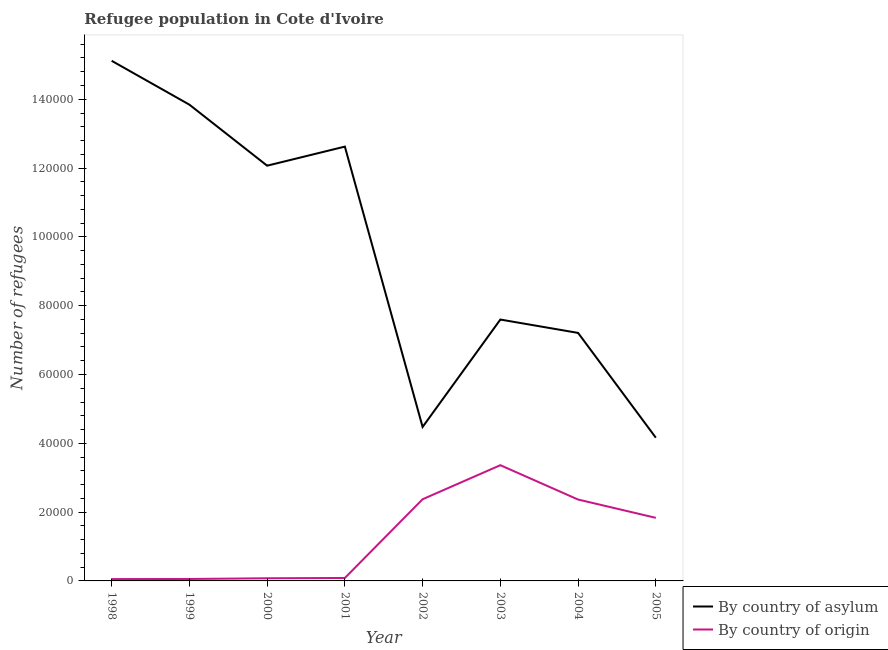Does the line corresponding to number of refugees by country of origin intersect with the line corresponding to number of refugees by country of asylum?
Provide a short and direct response. No. Is the number of lines equal to the number of legend labels?
Give a very brief answer. Yes. What is the number of refugees by country of asylum in 2005?
Give a very brief answer. 4.16e+04. Across all years, what is the maximum number of refugees by country of asylum?
Your response must be concise. 1.51e+05. Across all years, what is the minimum number of refugees by country of origin?
Your answer should be very brief. 537. In which year was the number of refugees by country of origin maximum?
Give a very brief answer. 2003. In which year was the number of refugees by country of origin minimum?
Your answer should be very brief. 1998. What is the total number of refugees by country of origin in the graph?
Ensure brevity in your answer.  1.02e+05. What is the difference between the number of refugees by country of origin in 1998 and that in 2004?
Offer a terse response. -2.31e+04. What is the difference between the number of refugees by country of asylum in 2005 and the number of refugees by country of origin in 2001?
Provide a succinct answer. 4.08e+04. What is the average number of refugees by country of origin per year?
Offer a terse response. 1.28e+04. In the year 1998, what is the difference between the number of refugees by country of origin and number of refugees by country of asylum?
Provide a short and direct response. -1.51e+05. What is the ratio of the number of refugees by country of origin in 1998 to that in 2002?
Your response must be concise. 0.02. Is the difference between the number of refugees by country of asylum in 2003 and 2005 greater than the difference between the number of refugees by country of origin in 2003 and 2005?
Your response must be concise. Yes. What is the difference between the highest and the second highest number of refugees by country of asylum?
Offer a very short reply. 1.28e+04. What is the difference between the highest and the lowest number of refugees by country of origin?
Offer a terse response. 3.31e+04. Is the sum of the number of refugees by country of asylum in 2001 and 2003 greater than the maximum number of refugees by country of origin across all years?
Provide a succinct answer. Yes. Does the number of refugees by country of asylum monotonically increase over the years?
Provide a short and direct response. No. Is the number of refugees by country of origin strictly greater than the number of refugees by country of asylum over the years?
Your answer should be compact. No. How many lines are there?
Make the answer very short. 2. How many years are there in the graph?
Your response must be concise. 8. What is the difference between two consecutive major ticks on the Y-axis?
Provide a short and direct response. 2.00e+04. Does the graph contain any zero values?
Keep it short and to the point. No. Does the graph contain grids?
Your response must be concise. No. Where does the legend appear in the graph?
Offer a very short reply. Bottom right. How many legend labels are there?
Your answer should be compact. 2. What is the title of the graph?
Ensure brevity in your answer.  Refugee population in Cote d'Ivoire. What is the label or title of the Y-axis?
Your answer should be compact. Number of refugees. What is the Number of refugees of By country of asylum in 1998?
Make the answer very short. 1.51e+05. What is the Number of refugees of By country of origin in 1998?
Provide a short and direct response. 537. What is the Number of refugees in By country of asylum in 1999?
Your answer should be compact. 1.38e+05. What is the Number of refugees of By country of origin in 1999?
Provide a succinct answer. 562. What is the Number of refugees of By country of asylum in 2000?
Offer a terse response. 1.21e+05. What is the Number of refugees in By country of origin in 2000?
Ensure brevity in your answer.  773. What is the Number of refugees of By country of asylum in 2001?
Provide a short and direct response. 1.26e+05. What is the Number of refugees in By country of origin in 2001?
Your response must be concise. 858. What is the Number of refugees of By country of asylum in 2002?
Make the answer very short. 4.47e+04. What is the Number of refugees in By country of origin in 2002?
Give a very brief answer. 2.37e+04. What is the Number of refugees in By country of asylum in 2003?
Provide a short and direct response. 7.60e+04. What is the Number of refugees in By country of origin in 2003?
Ensure brevity in your answer.  3.36e+04. What is the Number of refugees of By country of asylum in 2004?
Offer a very short reply. 7.21e+04. What is the Number of refugees of By country of origin in 2004?
Your response must be concise. 2.37e+04. What is the Number of refugees in By country of asylum in 2005?
Your response must be concise. 4.16e+04. What is the Number of refugees in By country of origin in 2005?
Make the answer very short. 1.83e+04. Across all years, what is the maximum Number of refugees in By country of asylum?
Your answer should be very brief. 1.51e+05. Across all years, what is the maximum Number of refugees in By country of origin?
Your answer should be compact. 3.36e+04. Across all years, what is the minimum Number of refugees of By country of asylum?
Offer a terse response. 4.16e+04. Across all years, what is the minimum Number of refugees in By country of origin?
Make the answer very short. 537. What is the total Number of refugees in By country of asylum in the graph?
Your answer should be compact. 7.71e+05. What is the total Number of refugees of By country of origin in the graph?
Provide a succinct answer. 1.02e+05. What is the difference between the Number of refugees in By country of asylum in 1998 and that in 1999?
Your answer should be very brief. 1.28e+04. What is the difference between the Number of refugees in By country of asylum in 1998 and that in 2000?
Your answer should be very brief. 3.05e+04. What is the difference between the Number of refugees of By country of origin in 1998 and that in 2000?
Offer a very short reply. -236. What is the difference between the Number of refugees in By country of asylum in 1998 and that in 2001?
Your response must be concise. 2.49e+04. What is the difference between the Number of refugees in By country of origin in 1998 and that in 2001?
Offer a terse response. -321. What is the difference between the Number of refugees in By country of asylum in 1998 and that in 2002?
Provide a succinct answer. 1.06e+05. What is the difference between the Number of refugees in By country of origin in 1998 and that in 2002?
Provide a succinct answer. -2.32e+04. What is the difference between the Number of refugees in By country of asylum in 1998 and that in 2003?
Ensure brevity in your answer.  7.52e+04. What is the difference between the Number of refugees of By country of origin in 1998 and that in 2003?
Provide a short and direct response. -3.31e+04. What is the difference between the Number of refugees of By country of asylum in 1998 and that in 2004?
Give a very brief answer. 7.91e+04. What is the difference between the Number of refugees in By country of origin in 1998 and that in 2004?
Provide a short and direct response. -2.31e+04. What is the difference between the Number of refugees of By country of asylum in 1998 and that in 2005?
Ensure brevity in your answer.  1.10e+05. What is the difference between the Number of refugees in By country of origin in 1998 and that in 2005?
Offer a terse response. -1.78e+04. What is the difference between the Number of refugees of By country of asylum in 1999 and that in 2000?
Give a very brief answer. 1.77e+04. What is the difference between the Number of refugees in By country of origin in 1999 and that in 2000?
Provide a succinct answer. -211. What is the difference between the Number of refugees in By country of asylum in 1999 and that in 2001?
Make the answer very short. 1.22e+04. What is the difference between the Number of refugees of By country of origin in 1999 and that in 2001?
Provide a succinct answer. -296. What is the difference between the Number of refugees of By country of asylum in 1999 and that in 2002?
Your answer should be compact. 9.37e+04. What is the difference between the Number of refugees in By country of origin in 1999 and that in 2002?
Ensure brevity in your answer.  -2.32e+04. What is the difference between the Number of refugees in By country of asylum in 1999 and that in 2003?
Provide a short and direct response. 6.25e+04. What is the difference between the Number of refugees of By country of origin in 1999 and that in 2003?
Your answer should be compact. -3.31e+04. What is the difference between the Number of refugees of By country of asylum in 1999 and that in 2004?
Your response must be concise. 6.63e+04. What is the difference between the Number of refugees of By country of origin in 1999 and that in 2004?
Give a very brief answer. -2.31e+04. What is the difference between the Number of refugees in By country of asylum in 1999 and that in 2005?
Give a very brief answer. 9.68e+04. What is the difference between the Number of refugees in By country of origin in 1999 and that in 2005?
Offer a terse response. -1.78e+04. What is the difference between the Number of refugees of By country of asylum in 2000 and that in 2001?
Your response must be concise. -5548. What is the difference between the Number of refugees in By country of origin in 2000 and that in 2001?
Your response must be concise. -85. What is the difference between the Number of refugees in By country of asylum in 2000 and that in 2002?
Offer a terse response. 7.59e+04. What is the difference between the Number of refugees in By country of origin in 2000 and that in 2002?
Provide a short and direct response. -2.30e+04. What is the difference between the Number of refugees of By country of asylum in 2000 and that in 2003?
Offer a terse response. 4.47e+04. What is the difference between the Number of refugees in By country of origin in 2000 and that in 2003?
Your answer should be compact. -3.29e+04. What is the difference between the Number of refugees of By country of asylum in 2000 and that in 2004?
Offer a very short reply. 4.86e+04. What is the difference between the Number of refugees of By country of origin in 2000 and that in 2004?
Ensure brevity in your answer.  -2.29e+04. What is the difference between the Number of refugees of By country of asylum in 2000 and that in 2005?
Offer a very short reply. 7.91e+04. What is the difference between the Number of refugees in By country of origin in 2000 and that in 2005?
Your response must be concise. -1.76e+04. What is the difference between the Number of refugees of By country of asylum in 2001 and that in 2002?
Make the answer very short. 8.15e+04. What is the difference between the Number of refugees in By country of origin in 2001 and that in 2002?
Make the answer very short. -2.29e+04. What is the difference between the Number of refugees in By country of asylum in 2001 and that in 2003?
Your response must be concise. 5.03e+04. What is the difference between the Number of refugees in By country of origin in 2001 and that in 2003?
Ensure brevity in your answer.  -3.28e+04. What is the difference between the Number of refugees in By country of asylum in 2001 and that in 2004?
Provide a succinct answer. 5.42e+04. What is the difference between the Number of refugees of By country of origin in 2001 and that in 2004?
Offer a very short reply. -2.28e+04. What is the difference between the Number of refugees of By country of asylum in 2001 and that in 2005?
Your answer should be very brief. 8.46e+04. What is the difference between the Number of refugees of By country of origin in 2001 and that in 2005?
Keep it short and to the point. -1.75e+04. What is the difference between the Number of refugees in By country of asylum in 2002 and that in 2003?
Your answer should be compact. -3.12e+04. What is the difference between the Number of refugees of By country of origin in 2002 and that in 2003?
Offer a terse response. -9896. What is the difference between the Number of refugees in By country of asylum in 2002 and that in 2004?
Keep it short and to the point. -2.73e+04. What is the difference between the Number of refugees of By country of asylum in 2002 and that in 2005?
Ensure brevity in your answer.  3122. What is the difference between the Number of refugees of By country of origin in 2002 and that in 2005?
Keep it short and to the point. 5403. What is the difference between the Number of refugees of By country of asylum in 2003 and that in 2004?
Your response must be concise. 3883. What is the difference between the Number of refugees of By country of origin in 2003 and that in 2004?
Provide a short and direct response. 9982. What is the difference between the Number of refugees of By country of asylum in 2003 and that in 2005?
Provide a short and direct response. 3.43e+04. What is the difference between the Number of refugees in By country of origin in 2003 and that in 2005?
Give a very brief answer. 1.53e+04. What is the difference between the Number of refugees in By country of asylum in 2004 and that in 2005?
Ensure brevity in your answer.  3.05e+04. What is the difference between the Number of refugees in By country of origin in 2004 and that in 2005?
Your response must be concise. 5317. What is the difference between the Number of refugees in By country of asylum in 1998 and the Number of refugees in By country of origin in 1999?
Provide a short and direct response. 1.51e+05. What is the difference between the Number of refugees of By country of asylum in 1998 and the Number of refugees of By country of origin in 2000?
Provide a succinct answer. 1.50e+05. What is the difference between the Number of refugees in By country of asylum in 1998 and the Number of refugees in By country of origin in 2001?
Keep it short and to the point. 1.50e+05. What is the difference between the Number of refugees of By country of asylum in 1998 and the Number of refugees of By country of origin in 2002?
Ensure brevity in your answer.  1.27e+05. What is the difference between the Number of refugees of By country of asylum in 1998 and the Number of refugees of By country of origin in 2003?
Give a very brief answer. 1.18e+05. What is the difference between the Number of refugees of By country of asylum in 1998 and the Number of refugees of By country of origin in 2004?
Provide a short and direct response. 1.28e+05. What is the difference between the Number of refugees of By country of asylum in 1998 and the Number of refugees of By country of origin in 2005?
Give a very brief answer. 1.33e+05. What is the difference between the Number of refugees of By country of asylum in 1999 and the Number of refugees of By country of origin in 2000?
Provide a succinct answer. 1.38e+05. What is the difference between the Number of refugees of By country of asylum in 1999 and the Number of refugees of By country of origin in 2001?
Your answer should be compact. 1.38e+05. What is the difference between the Number of refugees of By country of asylum in 1999 and the Number of refugees of By country of origin in 2002?
Give a very brief answer. 1.15e+05. What is the difference between the Number of refugees in By country of asylum in 1999 and the Number of refugees in By country of origin in 2003?
Your answer should be very brief. 1.05e+05. What is the difference between the Number of refugees in By country of asylum in 1999 and the Number of refugees in By country of origin in 2004?
Your answer should be very brief. 1.15e+05. What is the difference between the Number of refugees in By country of asylum in 1999 and the Number of refugees in By country of origin in 2005?
Keep it short and to the point. 1.20e+05. What is the difference between the Number of refugees of By country of asylum in 2000 and the Number of refugees of By country of origin in 2001?
Make the answer very short. 1.20e+05. What is the difference between the Number of refugees in By country of asylum in 2000 and the Number of refugees in By country of origin in 2002?
Your answer should be very brief. 9.70e+04. What is the difference between the Number of refugees of By country of asylum in 2000 and the Number of refugees of By country of origin in 2003?
Give a very brief answer. 8.71e+04. What is the difference between the Number of refugees of By country of asylum in 2000 and the Number of refugees of By country of origin in 2004?
Provide a short and direct response. 9.70e+04. What is the difference between the Number of refugees of By country of asylum in 2000 and the Number of refugees of By country of origin in 2005?
Your answer should be compact. 1.02e+05. What is the difference between the Number of refugees of By country of asylum in 2001 and the Number of refugees of By country of origin in 2002?
Offer a very short reply. 1.02e+05. What is the difference between the Number of refugees in By country of asylum in 2001 and the Number of refugees in By country of origin in 2003?
Your response must be concise. 9.26e+04. What is the difference between the Number of refugees of By country of asylum in 2001 and the Number of refugees of By country of origin in 2004?
Ensure brevity in your answer.  1.03e+05. What is the difference between the Number of refugees in By country of asylum in 2001 and the Number of refugees in By country of origin in 2005?
Offer a very short reply. 1.08e+05. What is the difference between the Number of refugees of By country of asylum in 2002 and the Number of refugees of By country of origin in 2003?
Your answer should be very brief. 1.11e+04. What is the difference between the Number of refugees of By country of asylum in 2002 and the Number of refugees of By country of origin in 2004?
Offer a terse response. 2.11e+04. What is the difference between the Number of refugees in By country of asylum in 2002 and the Number of refugees in By country of origin in 2005?
Offer a terse response. 2.64e+04. What is the difference between the Number of refugees of By country of asylum in 2003 and the Number of refugees of By country of origin in 2004?
Keep it short and to the point. 5.23e+04. What is the difference between the Number of refugees in By country of asylum in 2003 and the Number of refugees in By country of origin in 2005?
Give a very brief answer. 5.76e+04. What is the difference between the Number of refugees in By country of asylum in 2004 and the Number of refugees in By country of origin in 2005?
Your response must be concise. 5.38e+04. What is the average Number of refugees in By country of asylum per year?
Give a very brief answer. 9.64e+04. What is the average Number of refugees in By country of origin per year?
Ensure brevity in your answer.  1.28e+04. In the year 1998, what is the difference between the Number of refugees in By country of asylum and Number of refugees in By country of origin?
Keep it short and to the point. 1.51e+05. In the year 1999, what is the difference between the Number of refugees of By country of asylum and Number of refugees of By country of origin?
Offer a very short reply. 1.38e+05. In the year 2000, what is the difference between the Number of refugees in By country of asylum and Number of refugees in By country of origin?
Keep it short and to the point. 1.20e+05. In the year 2001, what is the difference between the Number of refugees of By country of asylum and Number of refugees of By country of origin?
Give a very brief answer. 1.25e+05. In the year 2002, what is the difference between the Number of refugees in By country of asylum and Number of refugees in By country of origin?
Keep it short and to the point. 2.10e+04. In the year 2003, what is the difference between the Number of refugees in By country of asylum and Number of refugees in By country of origin?
Keep it short and to the point. 4.23e+04. In the year 2004, what is the difference between the Number of refugees in By country of asylum and Number of refugees in By country of origin?
Your answer should be very brief. 4.84e+04. In the year 2005, what is the difference between the Number of refugees of By country of asylum and Number of refugees of By country of origin?
Your response must be concise. 2.33e+04. What is the ratio of the Number of refugees in By country of asylum in 1998 to that in 1999?
Provide a succinct answer. 1.09. What is the ratio of the Number of refugees in By country of origin in 1998 to that in 1999?
Keep it short and to the point. 0.96. What is the ratio of the Number of refugees of By country of asylum in 1998 to that in 2000?
Provide a succinct answer. 1.25. What is the ratio of the Number of refugees in By country of origin in 1998 to that in 2000?
Keep it short and to the point. 0.69. What is the ratio of the Number of refugees in By country of asylum in 1998 to that in 2001?
Ensure brevity in your answer.  1.2. What is the ratio of the Number of refugees in By country of origin in 1998 to that in 2001?
Provide a succinct answer. 0.63. What is the ratio of the Number of refugees of By country of asylum in 1998 to that in 2002?
Your response must be concise. 3.38. What is the ratio of the Number of refugees of By country of origin in 1998 to that in 2002?
Offer a very short reply. 0.02. What is the ratio of the Number of refugees of By country of asylum in 1998 to that in 2003?
Offer a very short reply. 1.99. What is the ratio of the Number of refugees in By country of origin in 1998 to that in 2003?
Your response must be concise. 0.02. What is the ratio of the Number of refugees in By country of asylum in 1998 to that in 2004?
Offer a terse response. 2.1. What is the ratio of the Number of refugees in By country of origin in 1998 to that in 2004?
Provide a short and direct response. 0.02. What is the ratio of the Number of refugees in By country of asylum in 1998 to that in 2005?
Ensure brevity in your answer.  3.63. What is the ratio of the Number of refugees of By country of origin in 1998 to that in 2005?
Your response must be concise. 0.03. What is the ratio of the Number of refugees in By country of asylum in 1999 to that in 2000?
Give a very brief answer. 1.15. What is the ratio of the Number of refugees of By country of origin in 1999 to that in 2000?
Provide a short and direct response. 0.73. What is the ratio of the Number of refugees of By country of asylum in 1999 to that in 2001?
Give a very brief answer. 1.1. What is the ratio of the Number of refugees of By country of origin in 1999 to that in 2001?
Ensure brevity in your answer.  0.66. What is the ratio of the Number of refugees in By country of asylum in 1999 to that in 2002?
Offer a very short reply. 3.09. What is the ratio of the Number of refugees in By country of origin in 1999 to that in 2002?
Keep it short and to the point. 0.02. What is the ratio of the Number of refugees in By country of asylum in 1999 to that in 2003?
Your answer should be very brief. 1.82. What is the ratio of the Number of refugees of By country of origin in 1999 to that in 2003?
Provide a short and direct response. 0.02. What is the ratio of the Number of refugees in By country of asylum in 1999 to that in 2004?
Your answer should be very brief. 1.92. What is the ratio of the Number of refugees of By country of origin in 1999 to that in 2004?
Your answer should be very brief. 0.02. What is the ratio of the Number of refugees in By country of asylum in 1999 to that in 2005?
Offer a terse response. 3.33. What is the ratio of the Number of refugees of By country of origin in 1999 to that in 2005?
Your answer should be compact. 0.03. What is the ratio of the Number of refugees of By country of asylum in 2000 to that in 2001?
Provide a short and direct response. 0.96. What is the ratio of the Number of refugees in By country of origin in 2000 to that in 2001?
Provide a short and direct response. 0.9. What is the ratio of the Number of refugees in By country of asylum in 2000 to that in 2002?
Provide a short and direct response. 2.7. What is the ratio of the Number of refugees in By country of origin in 2000 to that in 2002?
Keep it short and to the point. 0.03. What is the ratio of the Number of refugees in By country of asylum in 2000 to that in 2003?
Your response must be concise. 1.59. What is the ratio of the Number of refugees of By country of origin in 2000 to that in 2003?
Give a very brief answer. 0.02. What is the ratio of the Number of refugees in By country of asylum in 2000 to that in 2004?
Give a very brief answer. 1.67. What is the ratio of the Number of refugees in By country of origin in 2000 to that in 2004?
Offer a terse response. 0.03. What is the ratio of the Number of refugees in By country of asylum in 2000 to that in 2005?
Make the answer very short. 2.9. What is the ratio of the Number of refugees of By country of origin in 2000 to that in 2005?
Give a very brief answer. 0.04. What is the ratio of the Number of refugees of By country of asylum in 2001 to that in 2002?
Offer a very short reply. 2.82. What is the ratio of the Number of refugees of By country of origin in 2001 to that in 2002?
Ensure brevity in your answer.  0.04. What is the ratio of the Number of refugees of By country of asylum in 2001 to that in 2003?
Give a very brief answer. 1.66. What is the ratio of the Number of refugees of By country of origin in 2001 to that in 2003?
Provide a short and direct response. 0.03. What is the ratio of the Number of refugees in By country of asylum in 2001 to that in 2004?
Keep it short and to the point. 1.75. What is the ratio of the Number of refugees of By country of origin in 2001 to that in 2004?
Keep it short and to the point. 0.04. What is the ratio of the Number of refugees in By country of asylum in 2001 to that in 2005?
Offer a very short reply. 3.03. What is the ratio of the Number of refugees of By country of origin in 2001 to that in 2005?
Offer a very short reply. 0.05. What is the ratio of the Number of refugees of By country of asylum in 2002 to that in 2003?
Your response must be concise. 0.59. What is the ratio of the Number of refugees in By country of origin in 2002 to that in 2003?
Your answer should be very brief. 0.71. What is the ratio of the Number of refugees in By country of asylum in 2002 to that in 2004?
Keep it short and to the point. 0.62. What is the ratio of the Number of refugees of By country of asylum in 2002 to that in 2005?
Offer a very short reply. 1.07. What is the ratio of the Number of refugees in By country of origin in 2002 to that in 2005?
Ensure brevity in your answer.  1.29. What is the ratio of the Number of refugees in By country of asylum in 2003 to that in 2004?
Offer a very short reply. 1.05. What is the ratio of the Number of refugees in By country of origin in 2003 to that in 2004?
Make the answer very short. 1.42. What is the ratio of the Number of refugees of By country of asylum in 2003 to that in 2005?
Your answer should be very brief. 1.82. What is the ratio of the Number of refugees of By country of origin in 2003 to that in 2005?
Your answer should be compact. 1.83. What is the ratio of the Number of refugees in By country of asylum in 2004 to that in 2005?
Your answer should be very brief. 1.73. What is the ratio of the Number of refugees in By country of origin in 2004 to that in 2005?
Your response must be concise. 1.29. What is the difference between the highest and the second highest Number of refugees in By country of asylum?
Ensure brevity in your answer.  1.28e+04. What is the difference between the highest and the second highest Number of refugees of By country of origin?
Ensure brevity in your answer.  9896. What is the difference between the highest and the lowest Number of refugees in By country of asylum?
Provide a short and direct response. 1.10e+05. What is the difference between the highest and the lowest Number of refugees of By country of origin?
Your answer should be very brief. 3.31e+04. 